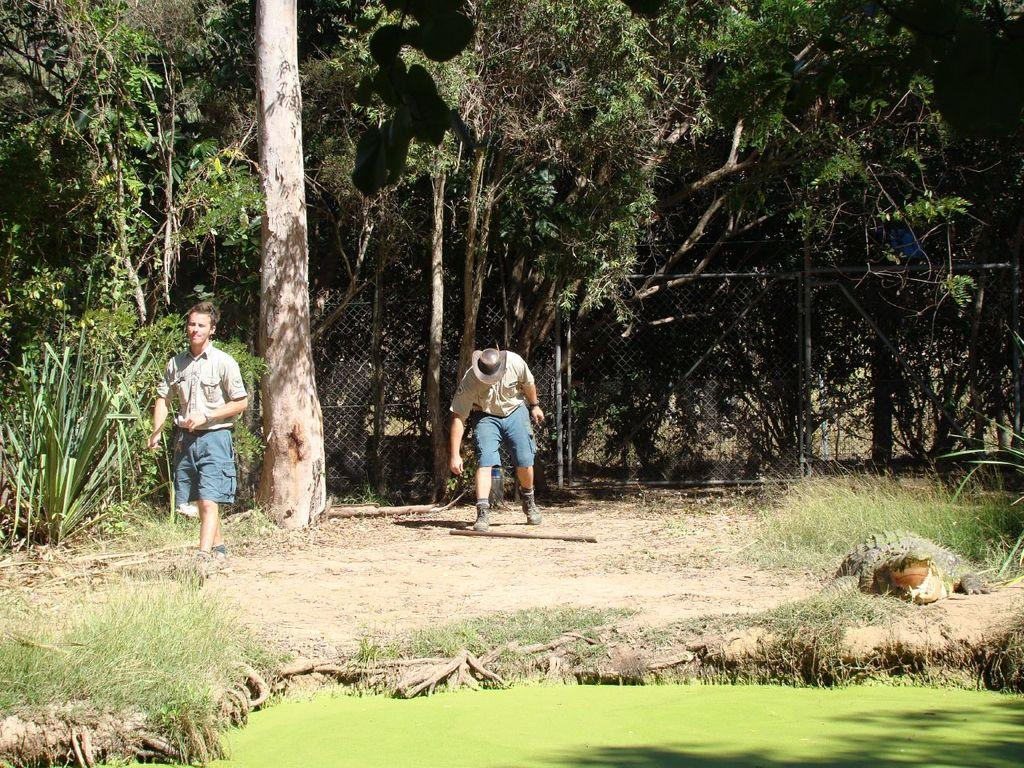How many people are in the image? There are two men in the image. What type of natural environment is visible in the image? There are trees, grass, and plants in the image. Can you see a rabbit playing volleyball in the image? There is no rabbit or volleyball present in the image. 